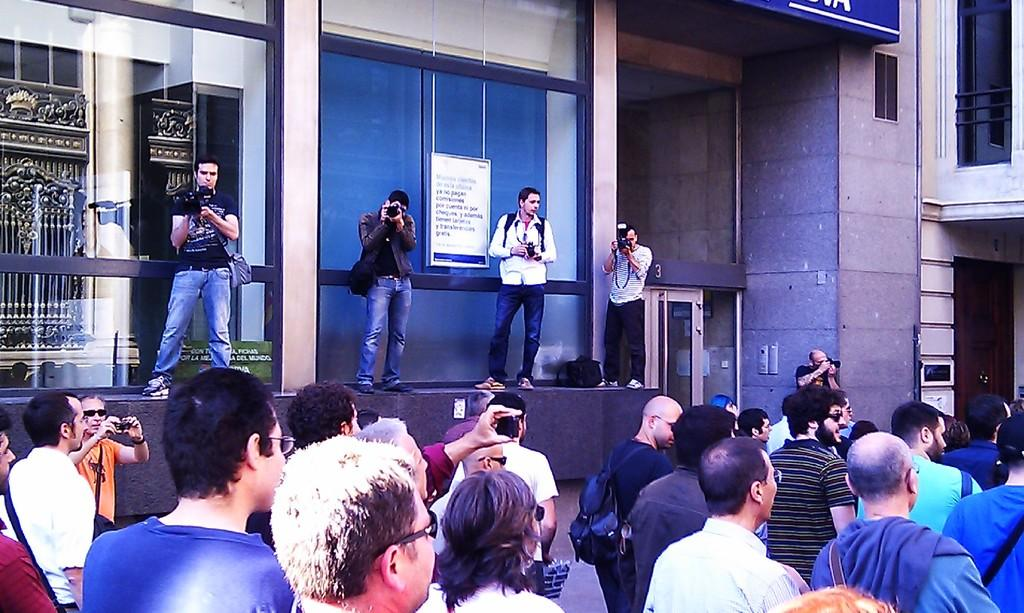What are the people at the bottom of the image doing? There are people standing at the bottom of the image, but their actions are not specified. What are the people in the middle of the image doing? The people in the middle of the image are holding cameras. What is the purpose of the wall visible in the image? The purpose of the wall is not specified in the provided facts. What type of zinc can be seen on the wall in the image? There is no zinc visible on the wall in the image. Is there a note attached to the wall in the image? The provided facts do not mention the presence of a note on the wall. Can you see a horse in the image? There is no horse present in the image. 